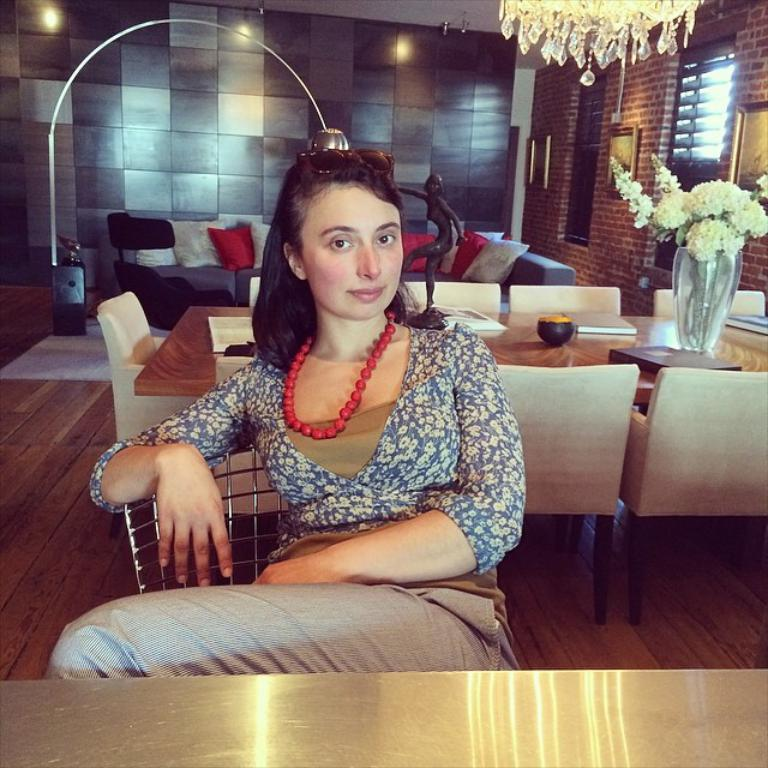Who is present in the image? There is a woman in the image. What is the woman doing in the image? The woman is sitting on a chair. What other furniture can be seen in the background of the image? There is a sofa in the background of the image. What type of houses can be seen in the background of the image? There are no houses visible in the background of the image; it only shows a woman sitting on a chair and a sofa in the background. 